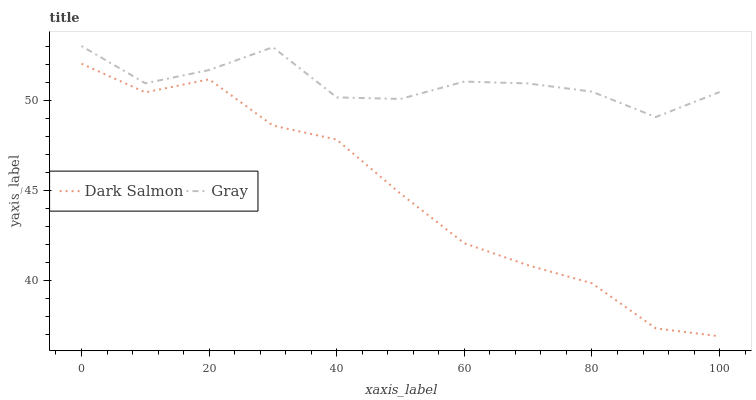Does Dark Salmon have the maximum area under the curve?
Answer yes or no. No. Is Dark Salmon the roughest?
Answer yes or no. No. Does Dark Salmon have the highest value?
Answer yes or no. No. Is Dark Salmon less than Gray?
Answer yes or no. Yes. Is Gray greater than Dark Salmon?
Answer yes or no. Yes. Does Dark Salmon intersect Gray?
Answer yes or no. No. 